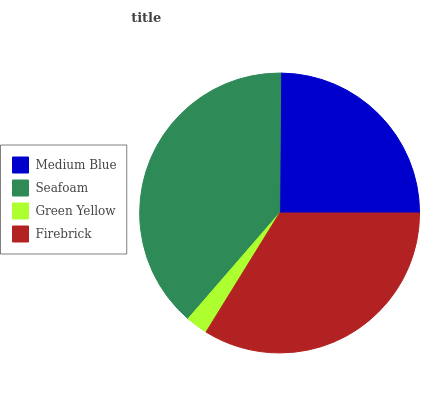Is Green Yellow the minimum?
Answer yes or no. Yes. Is Seafoam the maximum?
Answer yes or no. Yes. Is Seafoam the minimum?
Answer yes or no. No. Is Green Yellow the maximum?
Answer yes or no. No. Is Seafoam greater than Green Yellow?
Answer yes or no. Yes. Is Green Yellow less than Seafoam?
Answer yes or no. Yes. Is Green Yellow greater than Seafoam?
Answer yes or no. No. Is Seafoam less than Green Yellow?
Answer yes or no. No. Is Firebrick the high median?
Answer yes or no. Yes. Is Medium Blue the low median?
Answer yes or no. Yes. Is Medium Blue the high median?
Answer yes or no. No. Is Firebrick the low median?
Answer yes or no. No. 